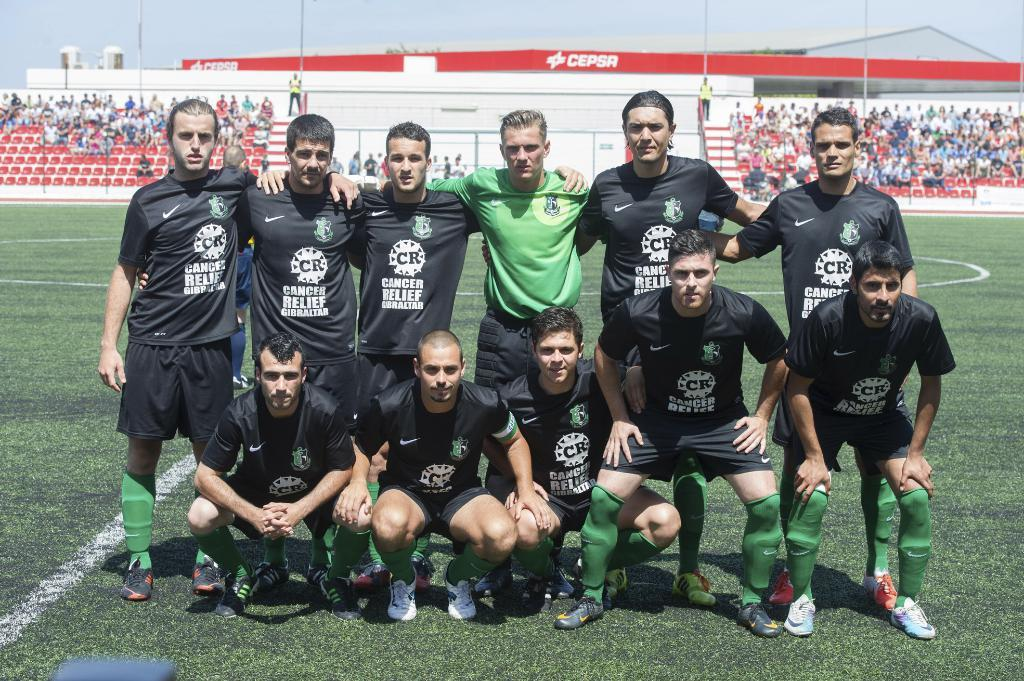Provide a one-sentence caption for the provided image. Several soccer players wear jerseys that feature the phrase "cancer relief". 